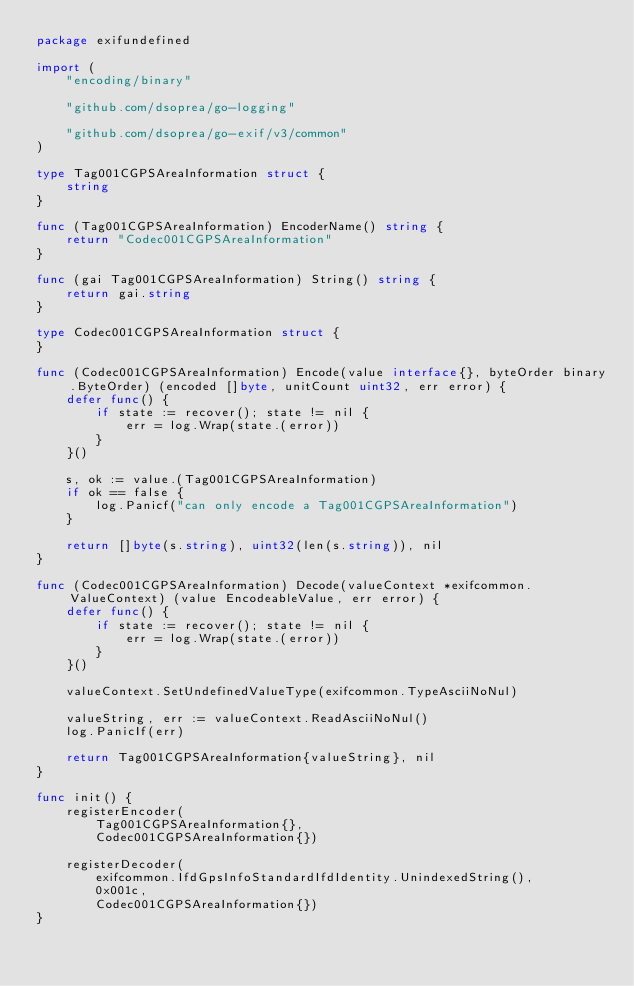Convert code to text. <code><loc_0><loc_0><loc_500><loc_500><_Go_>package exifundefined

import (
	"encoding/binary"

	"github.com/dsoprea/go-logging"

	"github.com/dsoprea/go-exif/v3/common"
)

type Tag001CGPSAreaInformation struct {
	string
}

func (Tag001CGPSAreaInformation) EncoderName() string {
	return "Codec001CGPSAreaInformation"
}

func (gai Tag001CGPSAreaInformation) String() string {
	return gai.string
}

type Codec001CGPSAreaInformation struct {
}

func (Codec001CGPSAreaInformation) Encode(value interface{}, byteOrder binary.ByteOrder) (encoded []byte, unitCount uint32, err error) {
	defer func() {
		if state := recover(); state != nil {
			err = log.Wrap(state.(error))
		}
	}()

	s, ok := value.(Tag001CGPSAreaInformation)
	if ok == false {
		log.Panicf("can only encode a Tag001CGPSAreaInformation")
	}

	return []byte(s.string), uint32(len(s.string)), nil
}

func (Codec001CGPSAreaInformation) Decode(valueContext *exifcommon.ValueContext) (value EncodeableValue, err error) {
	defer func() {
		if state := recover(); state != nil {
			err = log.Wrap(state.(error))
		}
	}()

	valueContext.SetUndefinedValueType(exifcommon.TypeAsciiNoNul)

	valueString, err := valueContext.ReadAsciiNoNul()
	log.PanicIf(err)

	return Tag001CGPSAreaInformation{valueString}, nil
}

func init() {
	registerEncoder(
		Tag001CGPSAreaInformation{},
		Codec001CGPSAreaInformation{})

	registerDecoder(
		exifcommon.IfdGpsInfoStandardIfdIdentity.UnindexedString(),
		0x001c,
		Codec001CGPSAreaInformation{})
}
</code> 